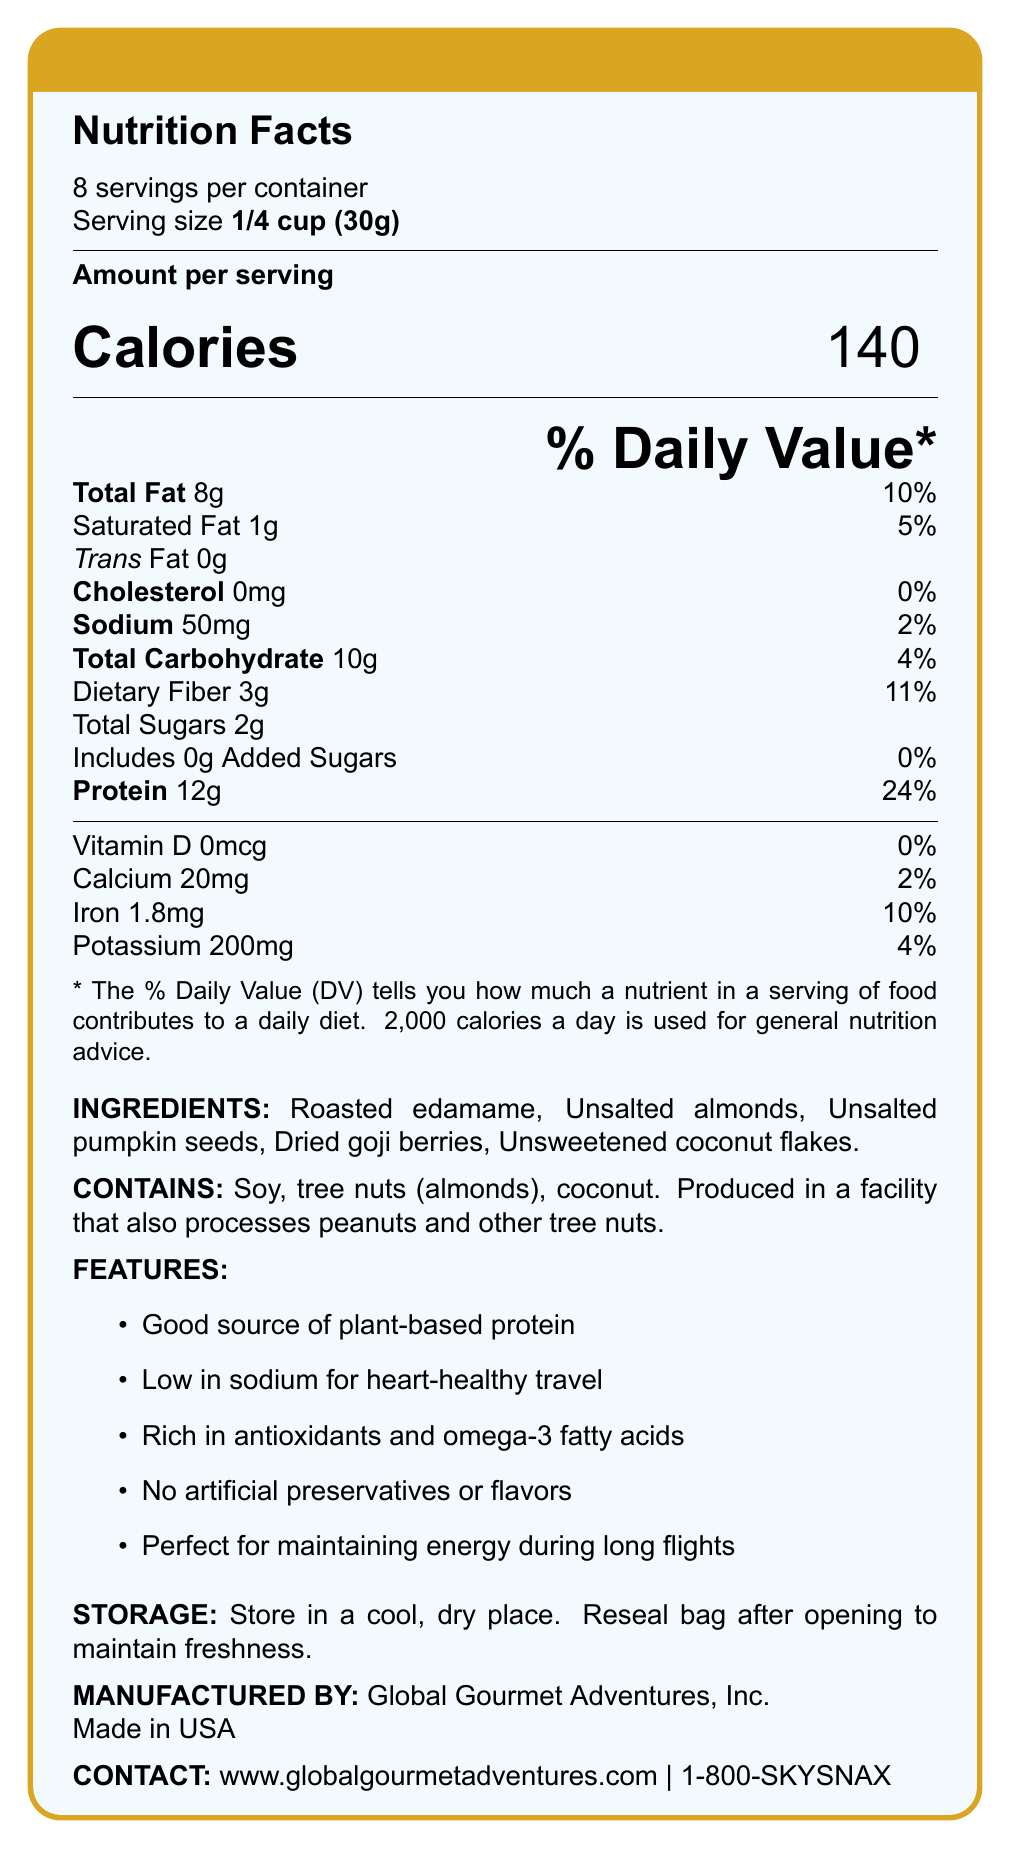What is the serving size for the SkySnax High-Protein Low-Sodium Travel Mix? The serving size is explicitly mentioned as "1/4 cup (30g)" in the document.
Answer: 1/4 cup (30g) How many calories are there per serving? The number of calories per serving is listed as 140 in the document.
Answer: 140 What is the amount of sodium in a single serving? Sodium content per serving is clearly stated as 50mg.
Answer: 50mg How much protein is in one serving of this travel mix? The document mentions that each serving contains 12g of protein.
Answer: 12g What allergens are present in the SkySnax Travel Mix? The allergen information specifies these ingredients.
Answer: Soy, tree nuts (almonds), coconut What is the daily value percentage for iron in one serving? The document indicates that the daily value percentage for iron is 10%.
Answer: 10% Does the SkySnax Travel Mix contain any trans fat? The document lists the trans fat amount as 0g.
Answer: No How many servings are there per container of the SkySnax Travel Mix? A. 6 B. 8 C. 10 D. 12 The document clearly states there are 8 servings per container.
Answer: B. 8 What is the amount of dietary fiber in one serving? A. 1g B. 2g C. 3g D. 4g The dietary fiber content per serving is listed as 3g in the document.
Answer: C. 3g Does this product contain any added sugars? It is specified in the document that there are 0g of added sugars.
Answer: No Is the SkySnax Travel Mix suitable for vegans? The document does not provide explicit information regarding the suitability of the product for a vegan diet.
Answer: Not enough information What are the storage instructions for this snack mix? The storage instructions are detailed in the document.
Answer: Store in a cool, dry place. Reseal bag after opening to maintain freshness. Summarize the key features and nutritional information of the SkySnax Travel Mix. This summary includes the main nutritional highlights and ingredient features mentioned in the document.
Answer: The SkySnax High-Protein Low-Sodium Travel Mix contains 12g of protein, 3g of dietary fiber, and has only 50mg of sodium per serving. It is a plant-based snack made from roasted edamame, almonds, pumpkin seeds, goji berries, and coconut flakes. It's enriched with antioxidants and omega-3 fatty acids, free from artificial preservatives or flavors, and is designed to maintain energy during long flights. How much calcium is in one serving? The calcium content per serving is listed as 20mg.
Answer: 20mg What is the contact information for customer service? The customer service number is provided as 1-800-SKYSNAX.
Answer: 1-800-SKYSNAX Which ingredient provides the most protein in the SkySnax Travel Mix? The document does not provide specific protein amounts for individual ingredients.
Answer: Cannot be determined 